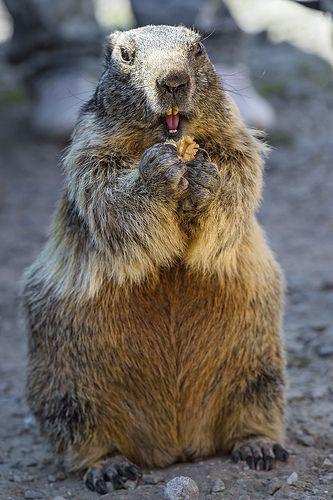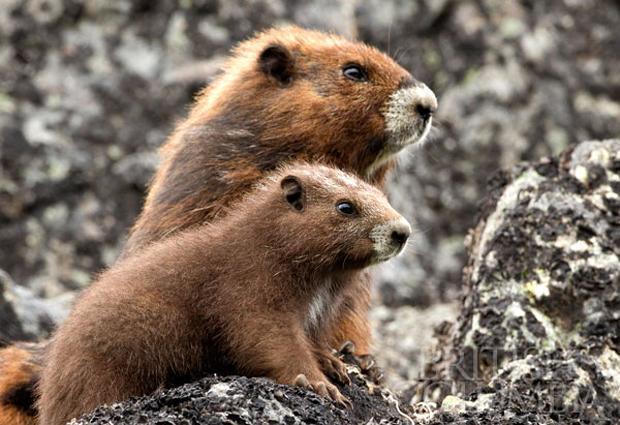The first image is the image on the left, the second image is the image on the right. Examine the images to the left and right. Is the description "At least one image contains two animals." accurate? Answer yes or no. Yes. 